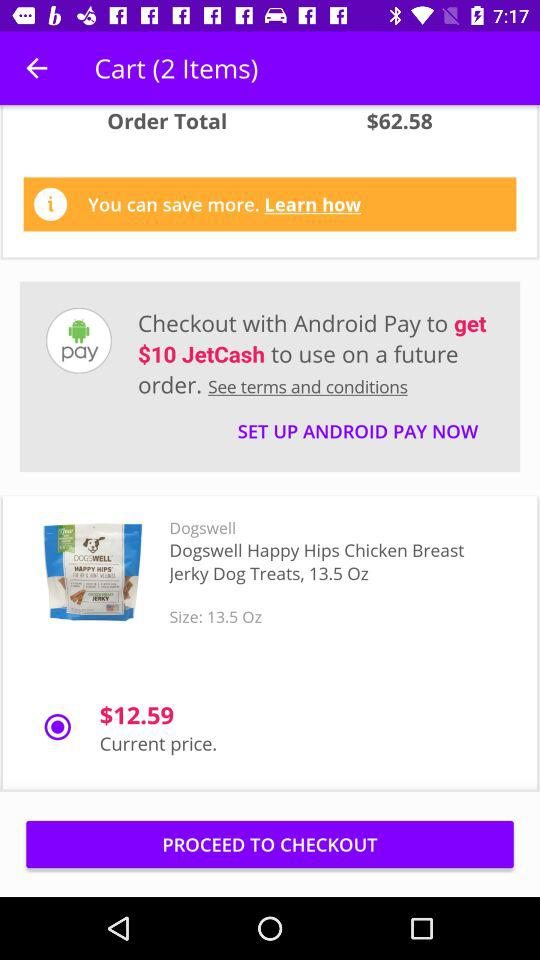How many items are in my cart?
Answer the question using a single word or phrase. 2 